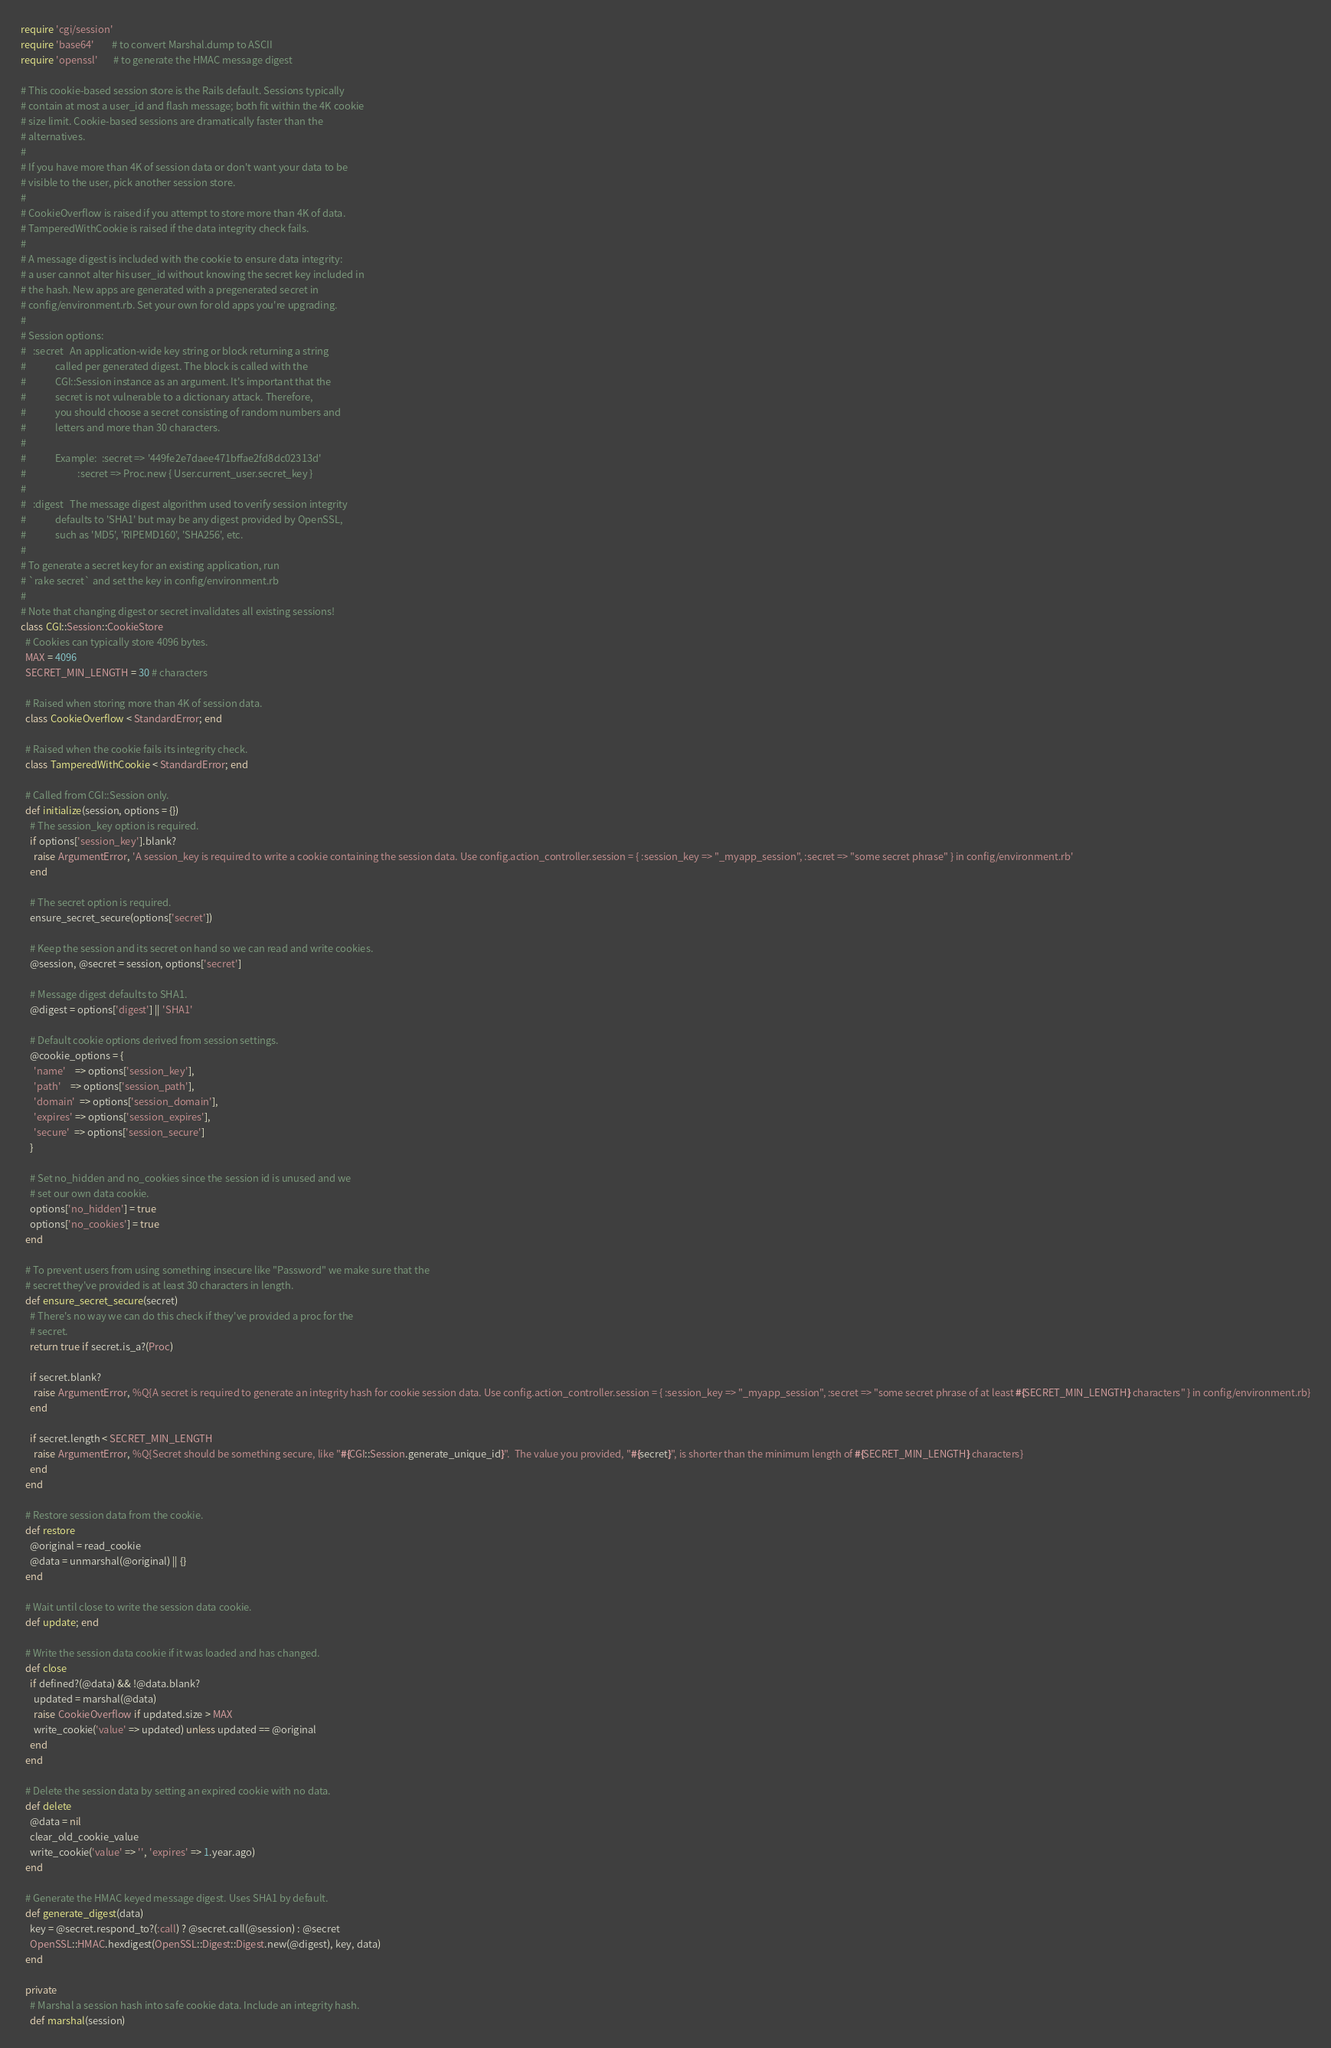<code> <loc_0><loc_0><loc_500><loc_500><_Ruby_>require 'cgi/session'
require 'base64'        # to convert Marshal.dump to ASCII
require 'openssl'       # to generate the HMAC message digest

# This cookie-based session store is the Rails default. Sessions typically
# contain at most a user_id and flash message; both fit within the 4K cookie
# size limit. Cookie-based sessions are dramatically faster than the
# alternatives.
#
# If you have more than 4K of session data or don't want your data to be
# visible to the user, pick another session store.
#
# CookieOverflow is raised if you attempt to store more than 4K of data.
# TamperedWithCookie is raised if the data integrity check fails.
#
# A message digest is included with the cookie to ensure data integrity:
# a user cannot alter his user_id without knowing the secret key included in
# the hash. New apps are generated with a pregenerated secret in
# config/environment.rb. Set your own for old apps you're upgrading.
#
# Session options:
#   :secret   An application-wide key string or block returning a string
#             called per generated digest. The block is called with the
#             CGI::Session instance as an argument. It's important that the
#             secret is not vulnerable to a dictionary attack. Therefore,
#             you should choose a secret consisting of random numbers and
#             letters and more than 30 characters.
#
#             Example:  :secret => '449fe2e7daee471bffae2fd8dc02313d'
#                       :secret => Proc.new { User.current_user.secret_key }
#
#   :digest   The message digest algorithm used to verify session integrity
#             defaults to 'SHA1' but may be any digest provided by OpenSSL,
#             such as 'MD5', 'RIPEMD160', 'SHA256', etc.
#
# To generate a secret key for an existing application, run
# `rake secret` and set the key in config/environment.rb
#
# Note that changing digest or secret invalidates all existing sessions!
class CGI::Session::CookieStore
  # Cookies can typically store 4096 bytes.
  MAX = 4096
  SECRET_MIN_LENGTH = 30 # characters

  # Raised when storing more than 4K of session data.
  class CookieOverflow < StandardError; end

  # Raised when the cookie fails its integrity check.
  class TamperedWithCookie < StandardError; end

  # Called from CGI::Session only.
  def initialize(session, options = {})
    # The session_key option is required.
    if options['session_key'].blank?
      raise ArgumentError, 'A session_key is required to write a cookie containing the session data. Use config.action_controller.session = { :session_key => "_myapp_session", :secret => "some secret phrase" } in config/environment.rb'
    end

    # The secret option is required.
    ensure_secret_secure(options['secret'])

    # Keep the session and its secret on hand so we can read and write cookies.
    @session, @secret = session, options['secret']

    # Message digest defaults to SHA1.
    @digest = options['digest'] || 'SHA1'

    # Default cookie options derived from session settings.
    @cookie_options = {
      'name'    => options['session_key'],
      'path'    => options['session_path'],
      'domain'  => options['session_domain'],
      'expires' => options['session_expires'],
      'secure'  => options['session_secure']
    }

    # Set no_hidden and no_cookies since the session id is unused and we
    # set our own data cookie.
    options['no_hidden'] = true
    options['no_cookies'] = true
  end

  # To prevent users from using something insecure like "Password" we make sure that the
  # secret they've provided is at least 30 characters in length.
  def ensure_secret_secure(secret)
    # There's no way we can do this check if they've provided a proc for the
    # secret.
    return true if secret.is_a?(Proc)

    if secret.blank?
      raise ArgumentError, %Q{A secret is required to generate an integrity hash for cookie session data. Use config.action_controller.session = { :session_key => "_myapp_session", :secret => "some secret phrase of at least #{SECRET_MIN_LENGTH} characters" } in config/environment.rb}
    end

    if secret.length < SECRET_MIN_LENGTH
      raise ArgumentError, %Q{Secret should be something secure, like "#{CGI::Session.generate_unique_id}".  The value you provided, "#{secret}", is shorter than the minimum length of #{SECRET_MIN_LENGTH} characters}
    end
  end

  # Restore session data from the cookie.
  def restore
    @original = read_cookie
    @data = unmarshal(@original) || {}
  end

  # Wait until close to write the session data cookie.
  def update; end

  # Write the session data cookie if it was loaded and has changed.
  def close
    if defined?(@data) && !@data.blank?
      updated = marshal(@data)
      raise CookieOverflow if updated.size > MAX
      write_cookie('value' => updated) unless updated == @original
    end
  end

  # Delete the session data by setting an expired cookie with no data.
  def delete
    @data = nil
    clear_old_cookie_value
    write_cookie('value' => '', 'expires' => 1.year.ago)
  end

  # Generate the HMAC keyed message digest. Uses SHA1 by default.
  def generate_digest(data)
    key = @secret.respond_to?(:call) ? @secret.call(@session) : @secret
    OpenSSL::HMAC.hexdigest(OpenSSL::Digest::Digest.new(@digest), key, data)
  end

  private
    # Marshal a session hash into safe cookie data. Include an integrity hash.
    def marshal(session)</code> 